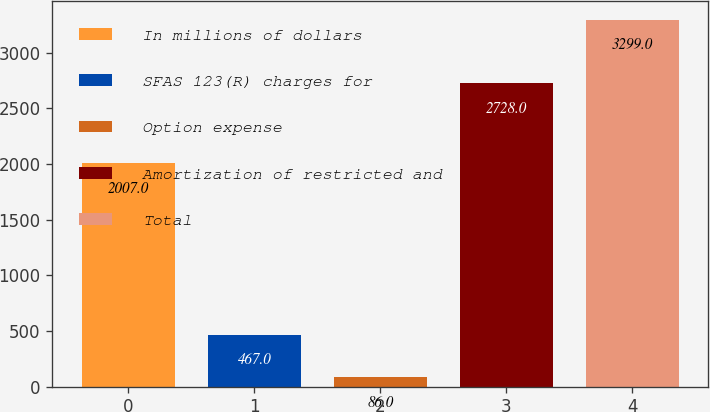Convert chart to OTSL. <chart><loc_0><loc_0><loc_500><loc_500><bar_chart><fcel>In millions of dollars<fcel>SFAS 123(R) charges for<fcel>Option expense<fcel>Amortization of restricted and<fcel>Total<nl><fcel>2007<fcel>467<fcel>86<fcel>2728<fcel>3299<nl></chart> 